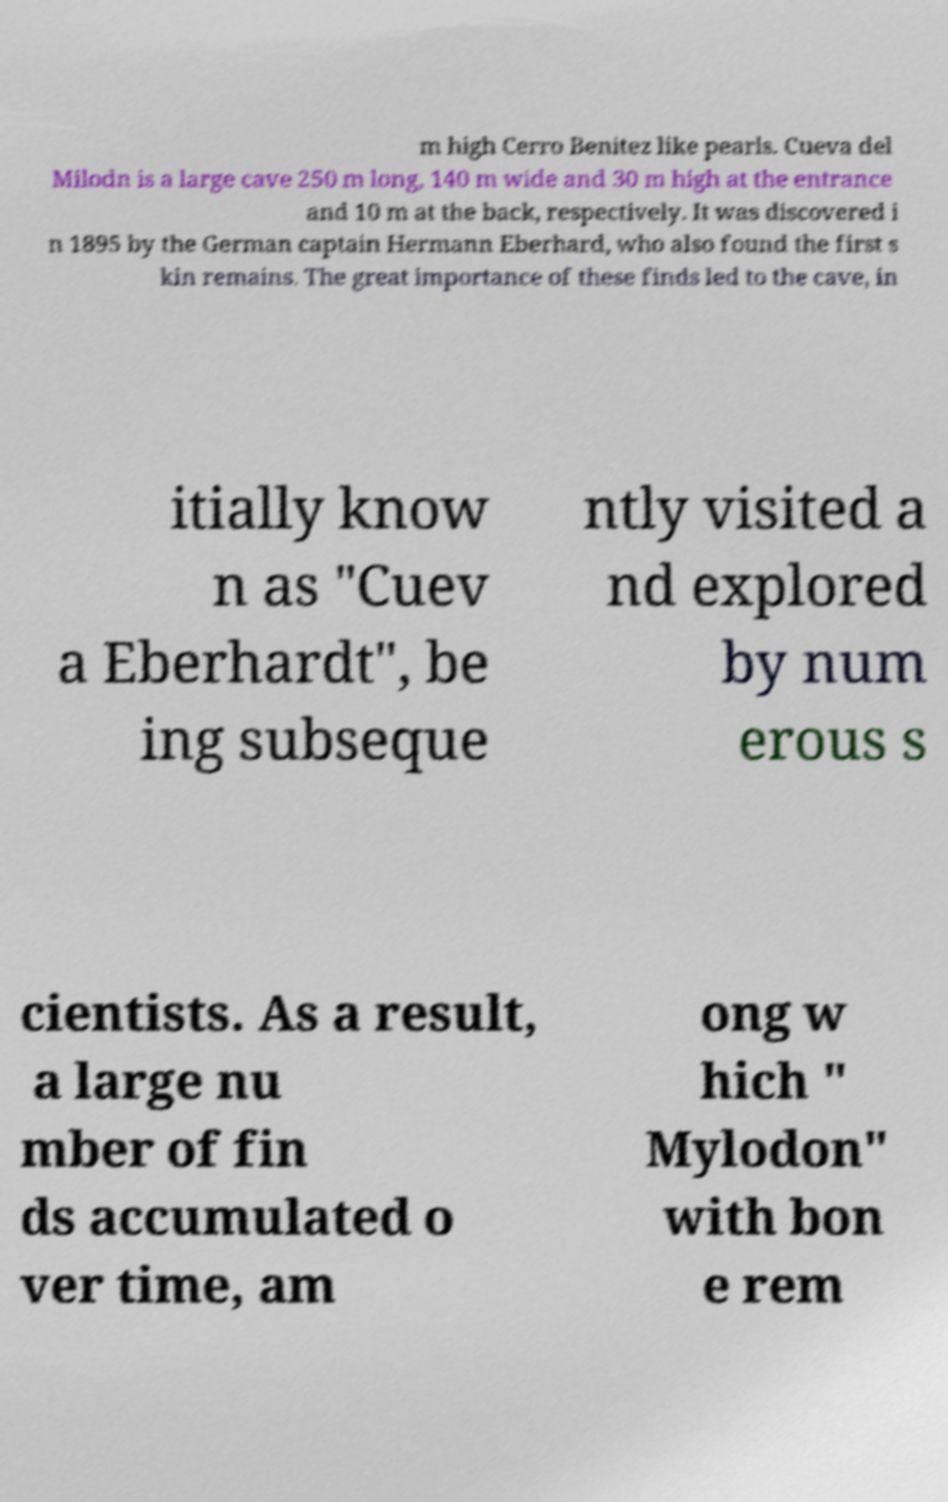Could you assist in decoding the text presented in this image and type it out clearly? m high Cerro Benitez like pearls. Cueva del Milodn is a large cave 250 m long, 140 m wide and 30 m high at the entrance and 10 m at the back, respectively. It was discovered i n 1895 by the German captain Hermann Eberhard, who also found the first s kin remains. The great importance of these finds led to the cave, in itially know n as "Cuev a Eberhardt", be ing subseque ntly visited a nd explored by num erous s cientists. As a result, a large nu mber of fin ds accumulated o ver time, am ong w hich " Mylodon" with bon e rem 